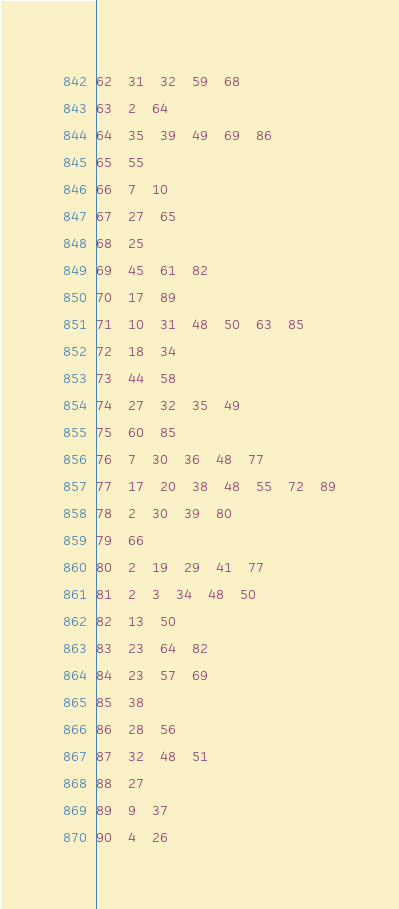<code> <loc_0><loc_0><loc_500><loc_500><_Perl_>62	31	32	59	68
63	2	64
64	35	39	49	69	86
65	55
66	7	10
67	27	65
68	25
69	45	61	82
70	17	89
71	10	31	48	50	63	85
72	18	34
73	44	58
74	27	32	35	49
75	60	85
76	7	30	36	48	77
77	17	20	38	48	55	72	89
78	2	30	39	80
79	66
80	2	19	29	41	77
81	2	3	34	48	50
82	13	50
83	23	64	82
84	23	57	69
85	38
86	28	56
87	32	48	51
88	27
89	9	37
90	4	26</code> 